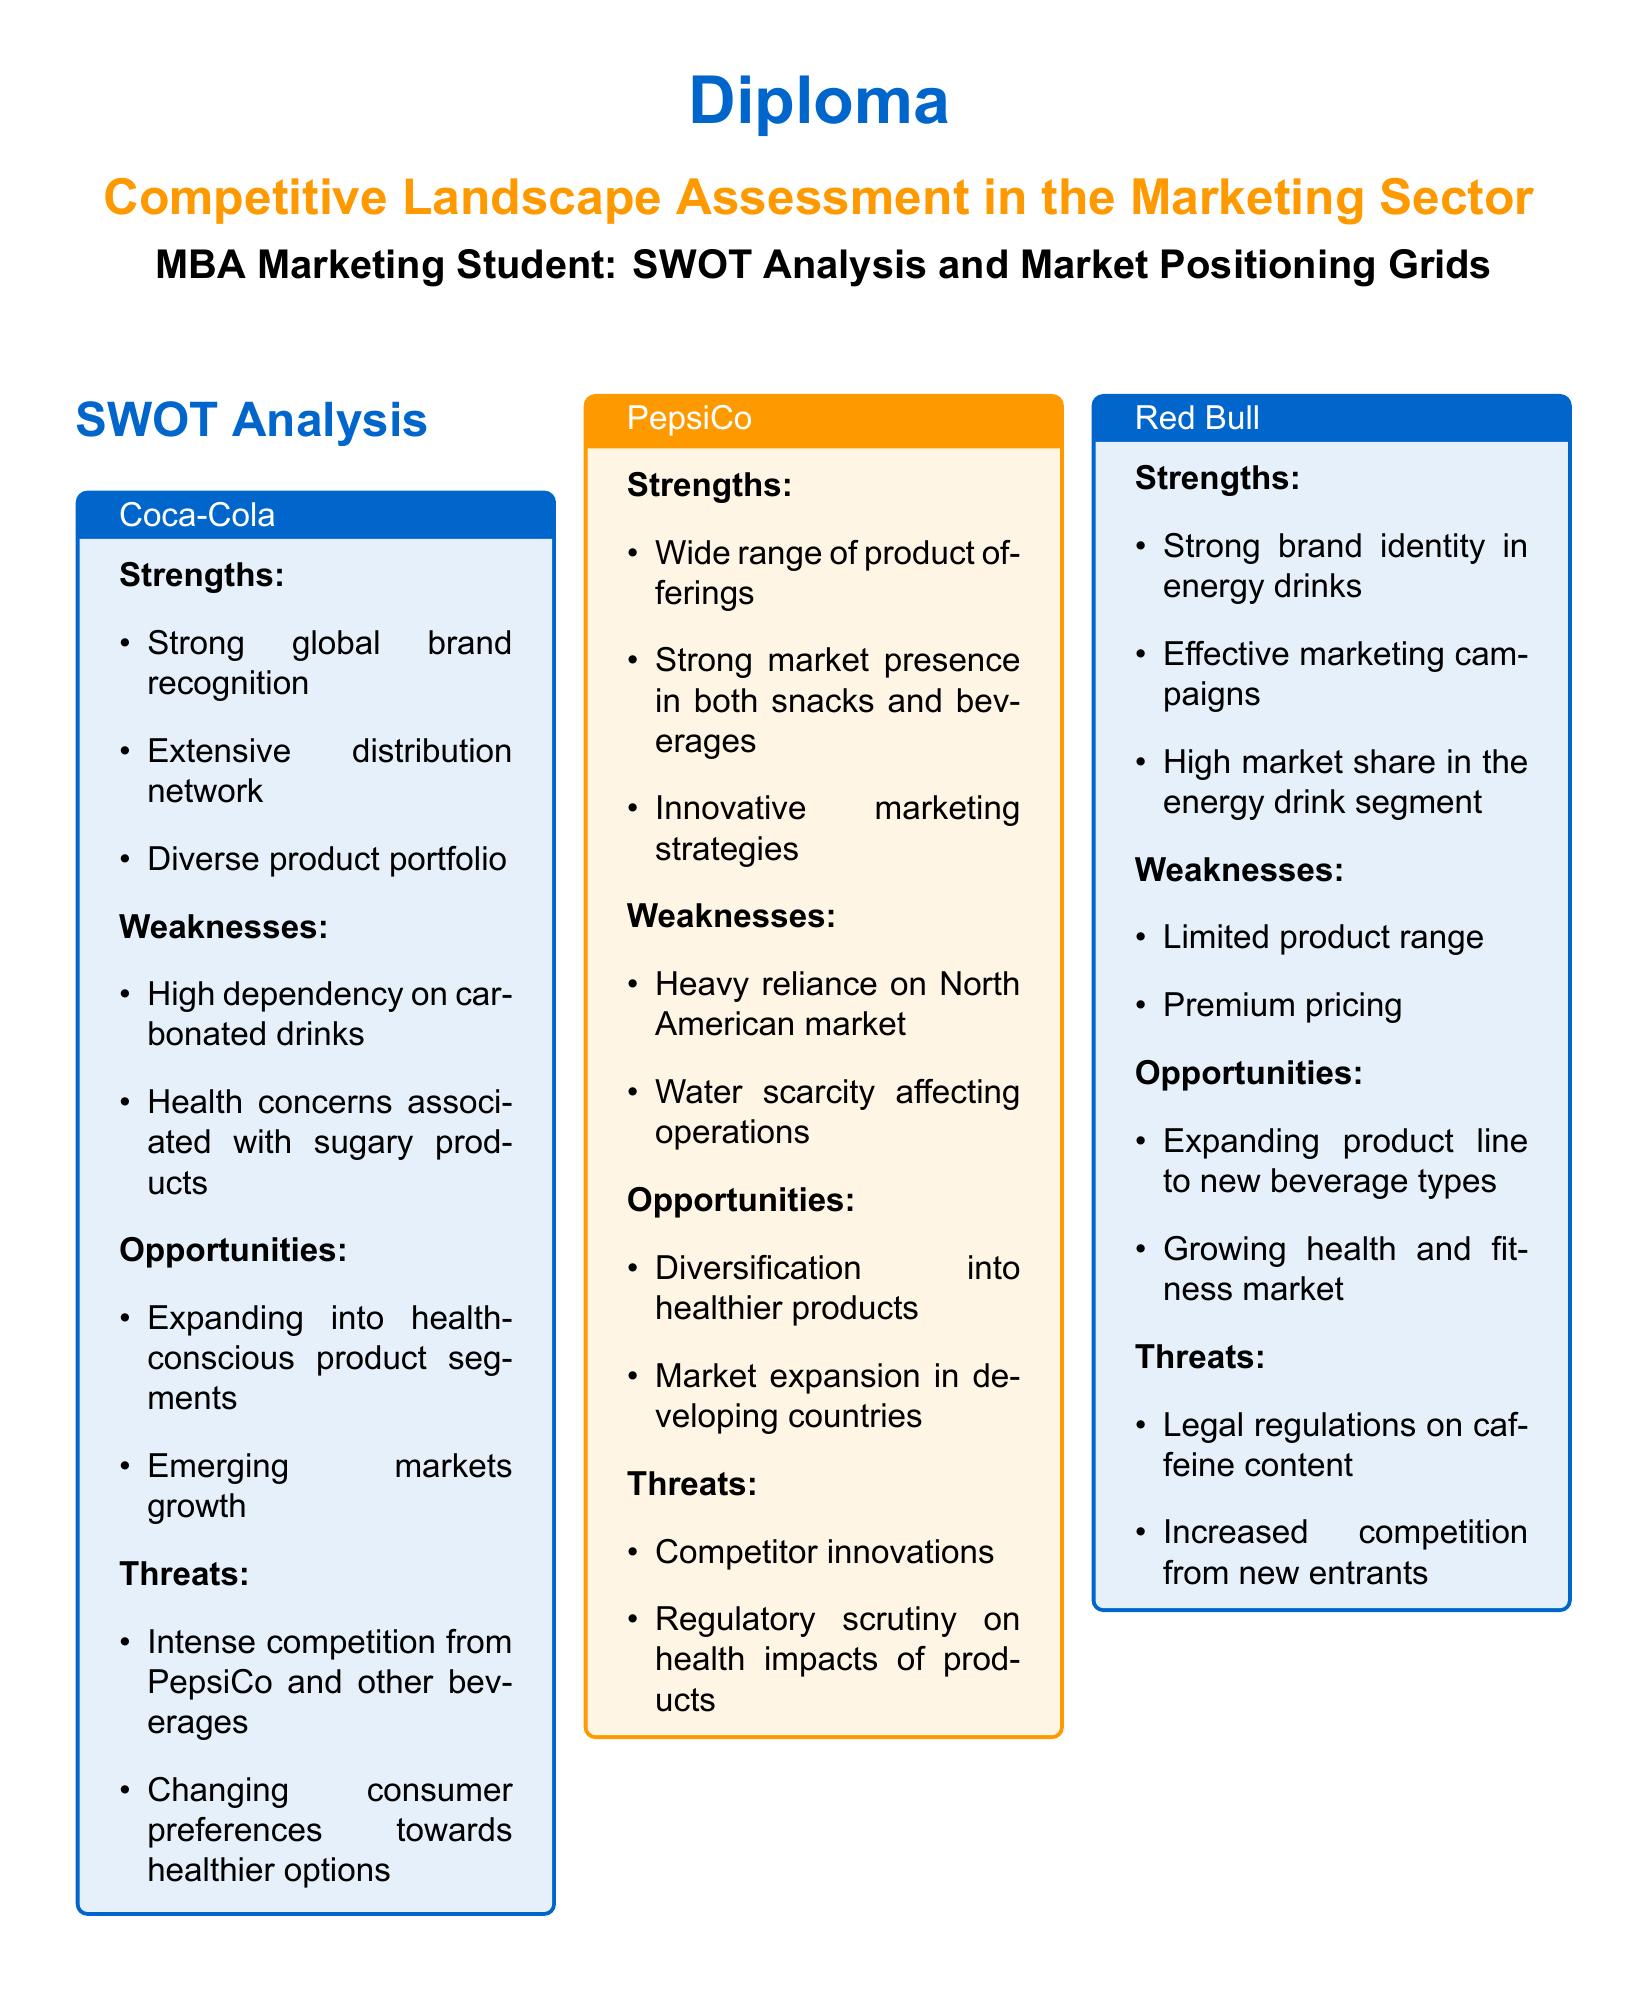What are the strengths of Coca-Cola? The strengths of Coca-Cola are listed in the SWOT analysis section, which includes strong global brand recognition, extensive distribution network, and diverse product portfolio.
Answer: Strong global brand recognition, extensive distribution network, diverse product portfolio What is the market share of Red Bull? The market share of Red Bull is indicated in the Market Positioning Grid table.
Answer: 70 What opportunities are noted for PepsiCo? The opportunities for PepsiCo are detailed in its SWOT analysis, highlighting diversification into healthier products and market expansion in developing countries.
Answer: Diversification into healthier products, market expansion in developing countries What is the brand strength of Coca-Cola? The brand strength of Coca-Cola is shown in the Market Positioning Grid table.
Answer: 95 Which company has the highest market share? The Market Positioning Grid shows Coca-Cola having the highest market share compared to other listed companies.
Answer: Coca-Cola What threat does Red Bull face regarding legal factors? The threats faced by Red Bull are included in its SWOT analysis, one of which mentions legal regulations on caffeine content.
Answer: Legal regulations on caffeine content What is the conclusion drawn from the competitive landscape assessment? The conclusion provides a summary of the dynamics among Coca-Cola, PepsiCo, and Red Bull, as well as the importance of the assessment for strategic marketing decisions.
Answer: The competitive landscape in the marketing of beverages shows a dynamic interplay between Coca-Cola, PepsiCo, and Red Bull What is the weakness of PepsiCo? The weaknesses for PepsiCo are listed in the SWOT analysis section, including heavy reliance on the North American market and water scarcity affecting operations.
Answer: Heavy reliance on North American market, water scarcity affecting operations What are the main companies assessed in the document? The document includes SWOT analyses for three main companies in the beverage market: Coca-Cola, PepsiCo, and Red Bull.
Answer: Coca-Cola, PepsiCo, Red Bull 